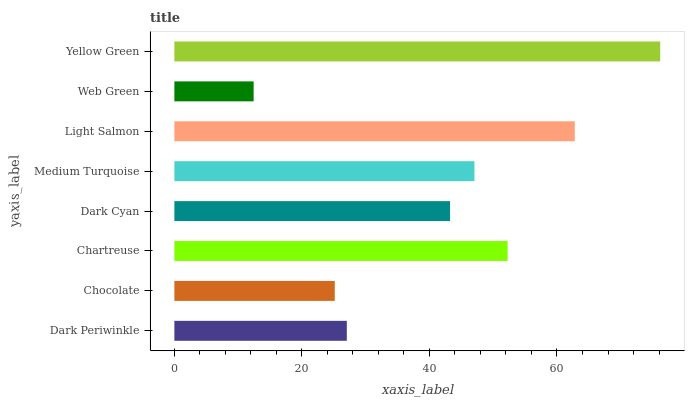Is Web Green the minimum?
Answer yes or no. Yes. Is Yellow Green the maximum?
Answer yes or no. Yes. Is Chocolate the minimum?
Answer yes or no. No. Is Chocolate the maximum?
Answer yes or no. No. Is Dark Periwinkle greater than Chocolate?
Answer yes or no. Yes. Is Chocolate less than Dark Periwinkle?
Answer yes or no. Yes. Is Chocolate greater than Dark Periwinkle?
Answer yes or no. No. Is Dark Periwinkle less than Chocolate?
Answer yes or no. No. Is Medium Turquoise the high median?
Answer yes or no. Yes. Is Dark Cyan the low median?
Answer yes or no. Yes. Is Dark Cyan the high median?
Answer yes or no. No. Is Light Salmon the low median?
Answer yes or no. No. 